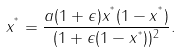Convert formula to latex. <formula><loc_0><loc_0><loc_500><loc_500>x ^ { ^ { * } } = \frac { a ( 1 + \epsilon ) x ^ { ^ { * } } ( 1 - x ^ { ^ { * } } ) } { ( 1 + \epsilon ( 1 - x ^ { ^ { * } } ) ) ^ { 2 } } .</formula> 